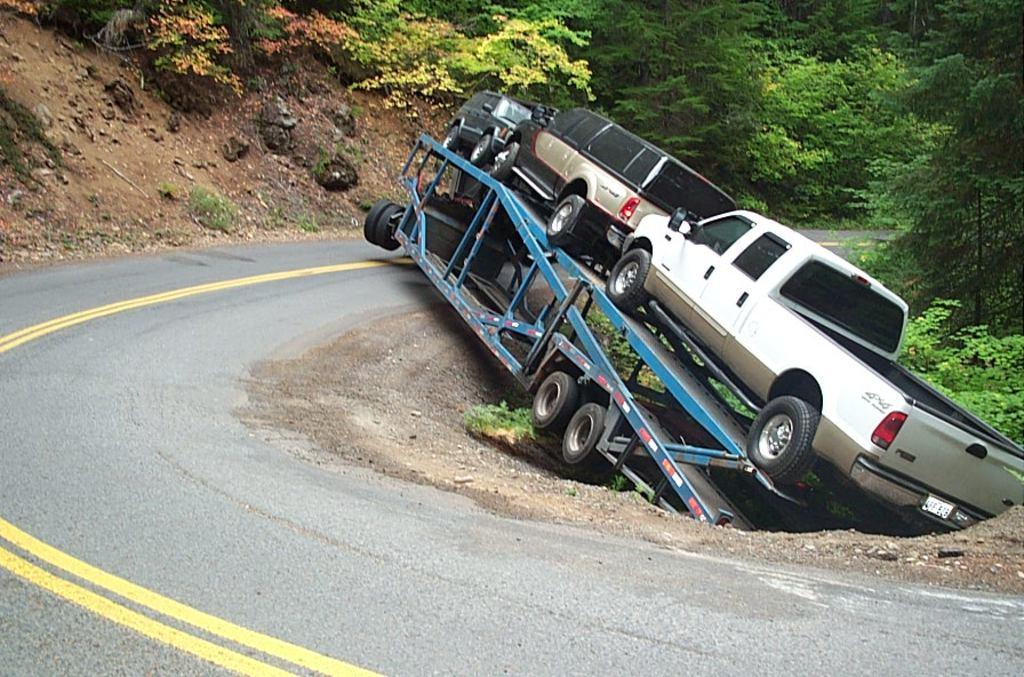What is the main subject of the image? There is a vehicle in the image. Can you describe the vehicle in more detail? There are three other vehicles on the main vehicle. What can be seen in the background of the image? There is a road visible in the image. What type of natural elements are present in the image? Stones, plants, and trees are present in the image. What action is the visitor performing in the image? There is no visitor present in the image, so no action can be attributed to a visitor. 